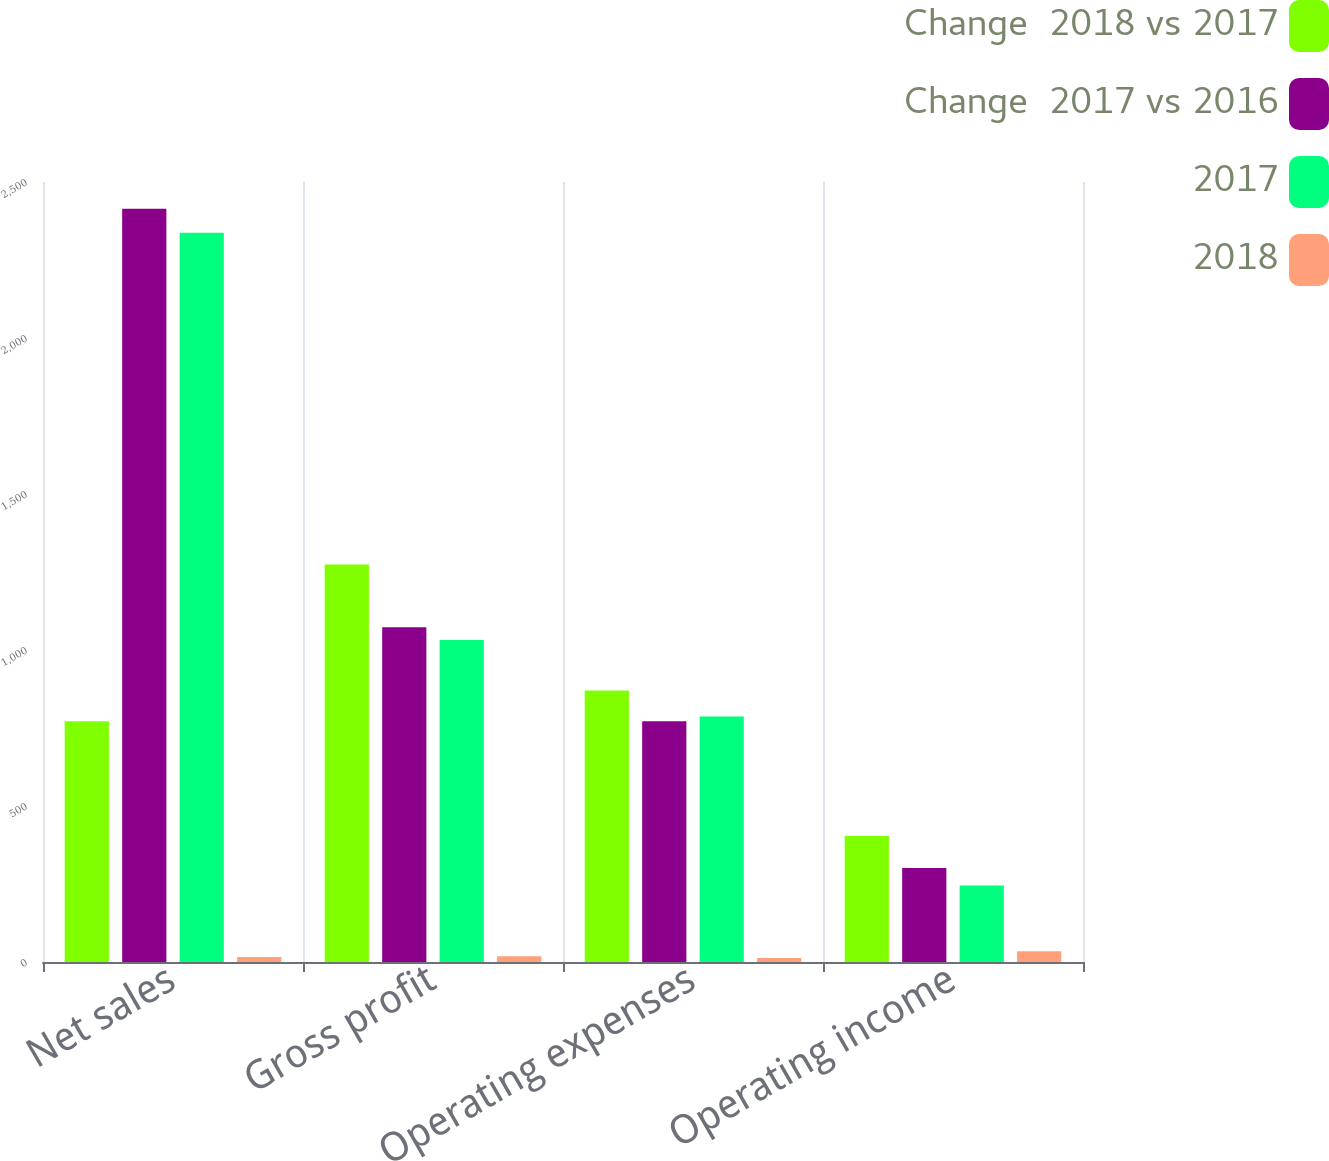<chart> <loc_0><loc_0><loc_500><loc_500><stacked_bar_chart><ecel><fcel>Net sales<fcel>Gross profit<fcel>Operating expenses<fcel>Operating income<nl><fcel>Change  2018 vs 2017<fcel>772<fcel>1274<fcel>870<fcel>404<nl><fcel>Change  2017 vs 2016<fcel>2414<fcel>1073<fcel>772<fcel>301<nl><fcel>2017<fcel>2337<fcel>1032<fcel>787<fcel>245<nl><fcel>2018<fcel>15.8<fcel>18.7<fcel>12.7<fcel>34.2<nl></chart> 